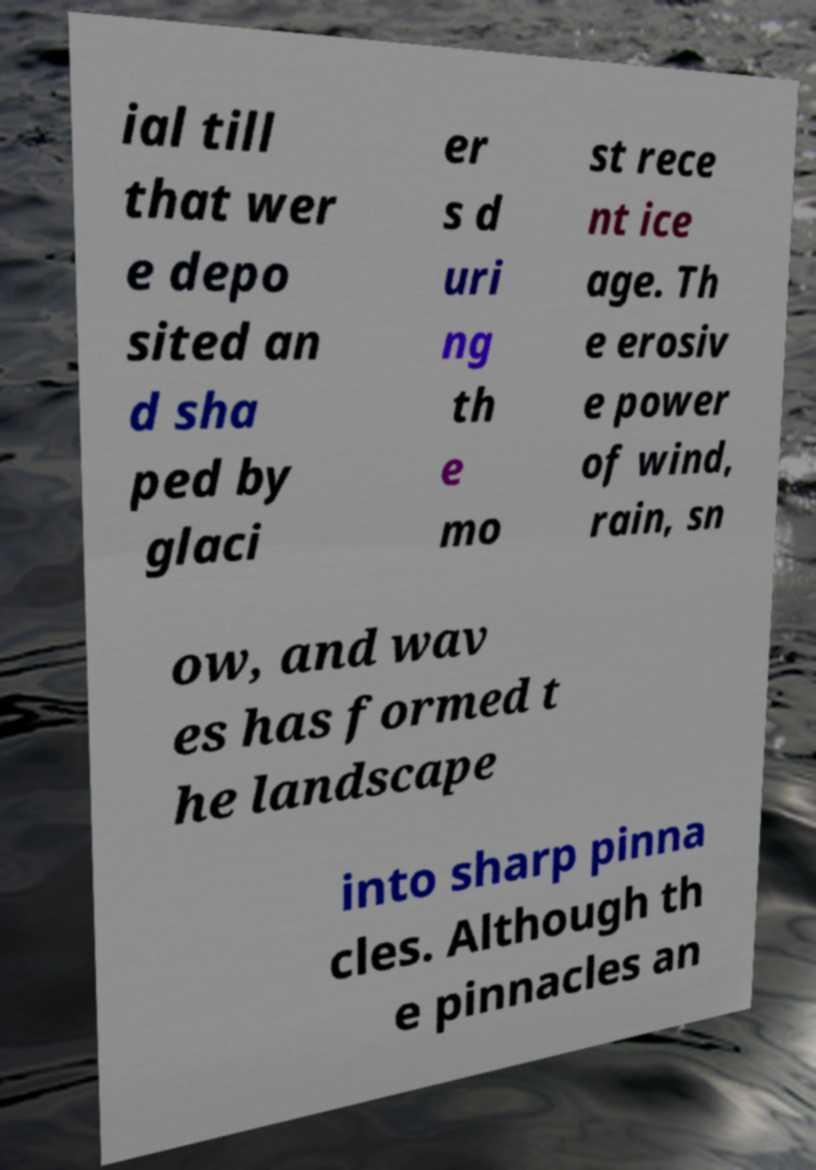Can you accurately transcribe the text from the provided image for me? ial till that wer e depo sited an d sha ped by glaci er s d uri ng th e mo st rece nt ice age. Th e erosiv e power of wind, rain, sn ow, and wav es has formed t he landscape into sharp pinna cles. Although th e pinnacles an 